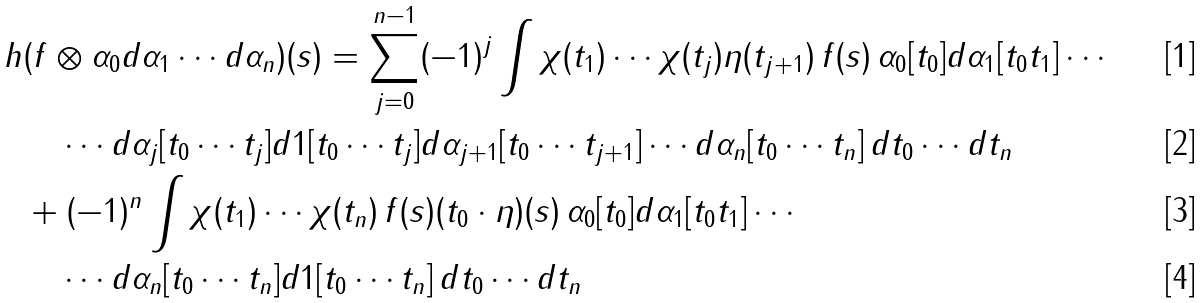Convert formula to latex. <formula><loc_0><loc_0><loc_500><loc_500>h & ( f \otimes \alpha _ { 0 } d \alpha _ { 1 } \cdots d \alpha _ { n } ) ( s ) = \sum _ { j = 0 } ^ { n - 1 } ( - 1 ) ^ { j } \int \chi ( t _ { 1 } ) \cdots \chi ( t _ { j } ) \eta ( t _ { j + 1 } ) \, f ( s ) \, \alpha _ { 0 } [ t _ { 0 } ] d \alpha _ { 1 } [ t _ { 0 } t _ { 1 } ] \cdots \\ & \quad \cdots d \alpha _ { j } [ t _ { 0 } \cdots t _ { j } ] d 1 [ t _ { 0 } \cdots t _ { j } ] d \alpha _ { j + 1 } [ t _ { 0 } \cdots t _ { j + 1 } ] \cdots d \alpha _ { n } [ t _ { 0 } \cdots t _ { n } ] \, d t _ { 0 } \cdots d t _ { n } \\ & + ( - 1 ) ^ { n } \int \chi ( t _ { 1 } ) \cdots \chi ( t _ { n } ) \, f ( s ) ( t _ { 0 } \cdot \eta ) ( s ) \, \alpha _ { 0 } [ t _ { 0 } ] d \alpha _ { 1 } [ t _ { 0 } t _ { 1 } ] \cdots \\ & \quad \cdots d \alpha _ { n } [ t _ { 0 } \cdots t _ { n } ] d 1 [ t _ { 0 } \cdots t _ { n } ] \, d t _ { 0 } \cdots d t _ { n }</formula> 